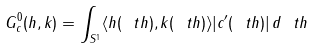Convert formula to latex. <formula><loc_0><loc_0><loc_500><loc_500>G ^ { 0 } _ { c } ( h , k ) = \int _ { S ^ { 1 } } \langle h ( \ t h ) , k ( \ t h ) \rangle | c ^ { \prime } ( \ t h ) | \, d \ t h</formula> 